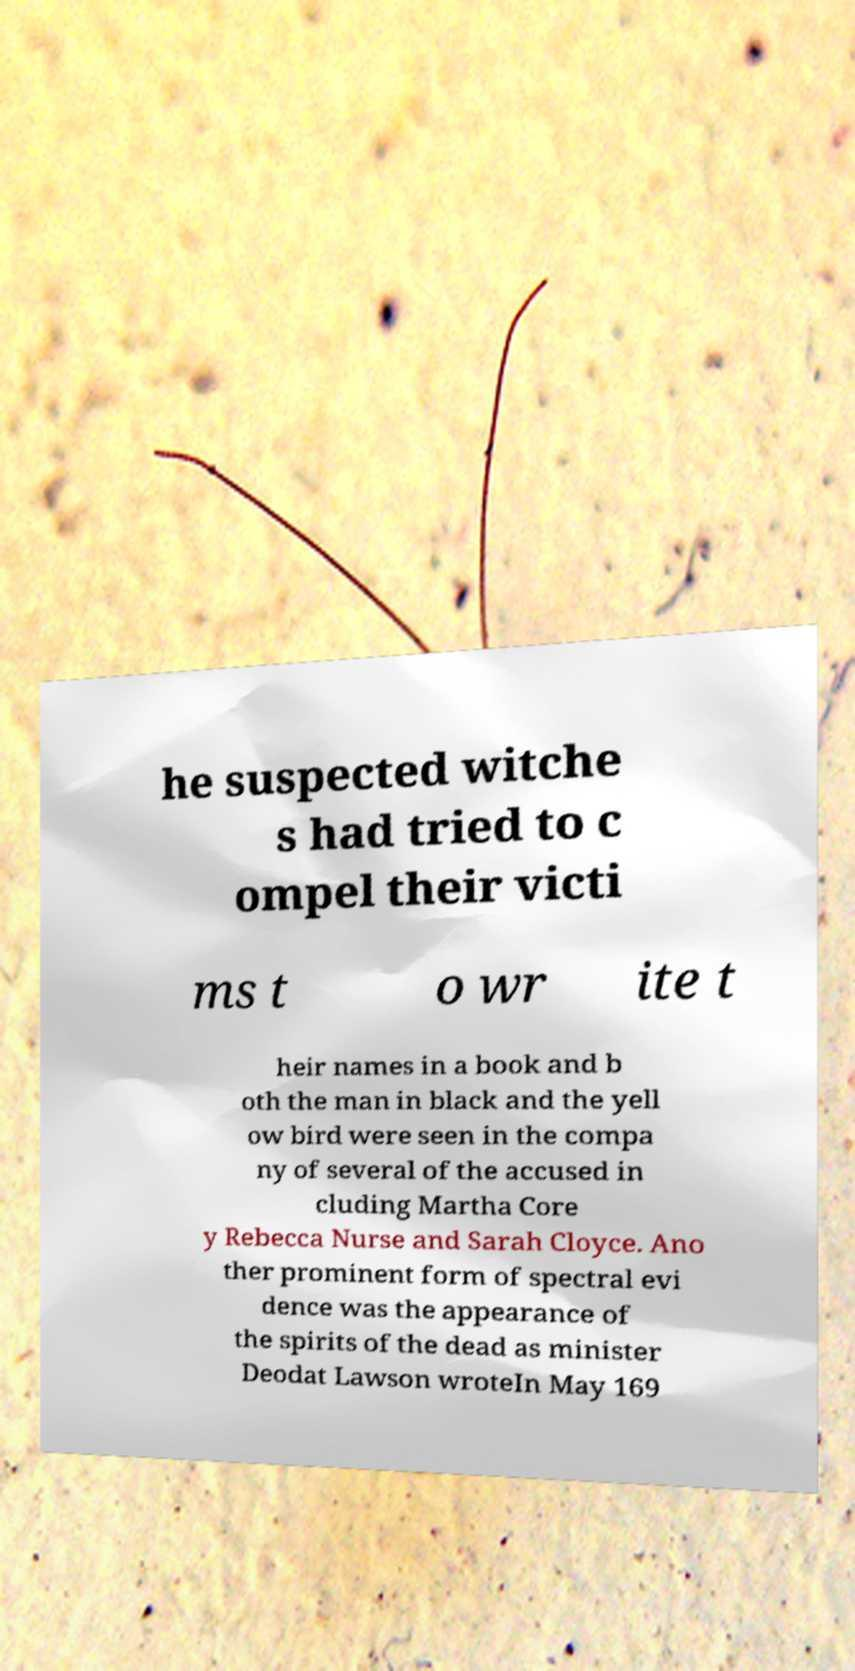Please read and relay the text visible in this image. What does it say? he suspected witche s had tried to c ompel their victi ms t o wr ite t heir names in a book and b oth the man in black and the yell ow bird were seen in the compa ny of several of the accused in cluding Martha Core y Rebecca Nurse and Sarah Cloyce. Ano ther prominent form of spectral evi dence was the appearance of the spirits of the dead as minister Deodat Lawson wroteIn May 169 